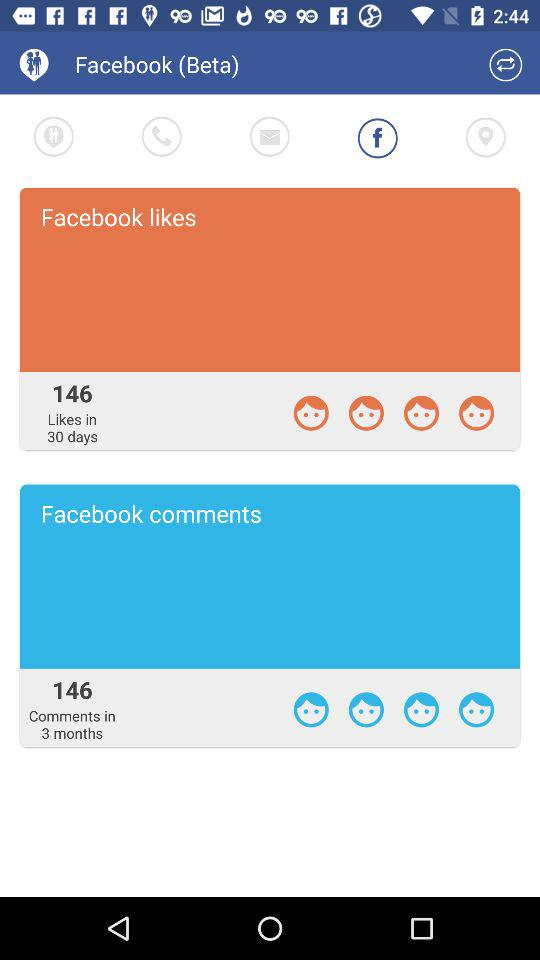How many "Facebook" likes are there? There are 146 "Facebook" likes. 